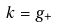<formula> <loc_0><loc_0><loc_500><loc_500>k = g _ { + }</formula> 